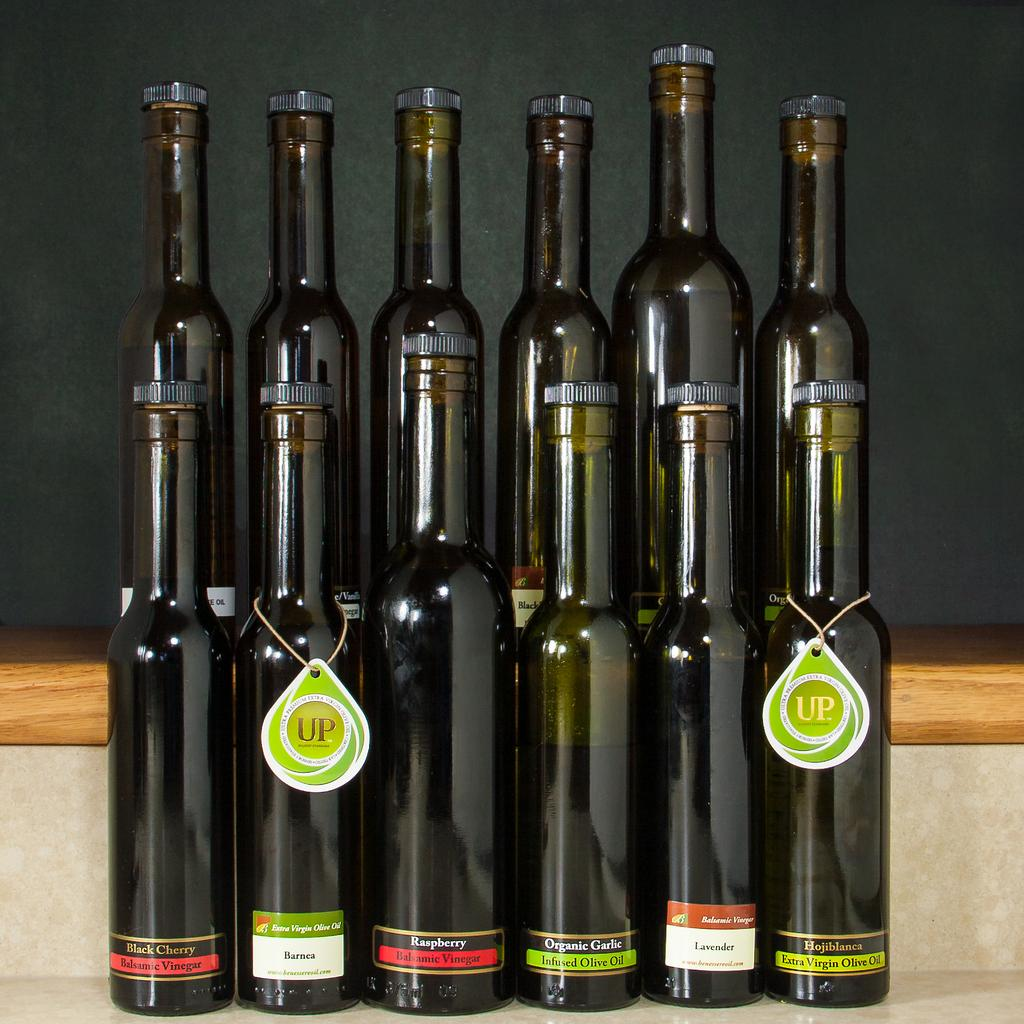<image>
Summarize the visual content of the image. A group of tall brown bottles with some of them bearing a tag that reads "Up". 